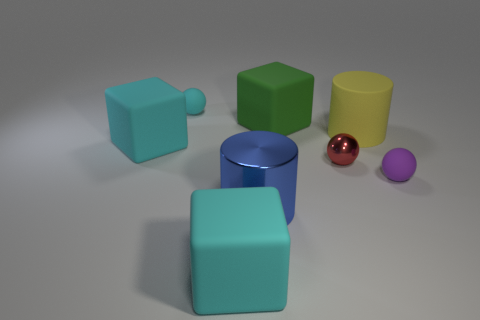There is a red object right of the cyan thing that is behind the large yellow matte thing; what is its material?
Offer a terse response. Metal. Are there more cubes behind the tiny red metal sphere than small gray metal objects?
Make the answer very short. Yes. Are there any red balls that have the same material as the blue thing?
Make the answer very short. Yes. There is a big blue thing in front of the tiny cyan ball; is it the same shape as the yellow object?
Your answer should be compact. Yes. What number of green rubber objects are to the right of the small rubber thing right of the big cylinder that is behind the red object?
Your answer should be compact. 0. Is the number of rubber cylinders that are behind the yellow thing less than the number of large things behind the large blue object?
Your answer should be compact. Yes. What is the color of the other big matte thing that is the same shape as the blue thing?
Offer a very short reply. Yellow. What is the size of the matte cylinder?
Make the answer very short. Large. How many purple balls have the same size as the purple rubber thing?
Make the answer very short. 0. Is the ball to the left of the green matte object made of the same material as the large cylinder that is to the right of the big green thing?
Offer a terse response. Yes. 